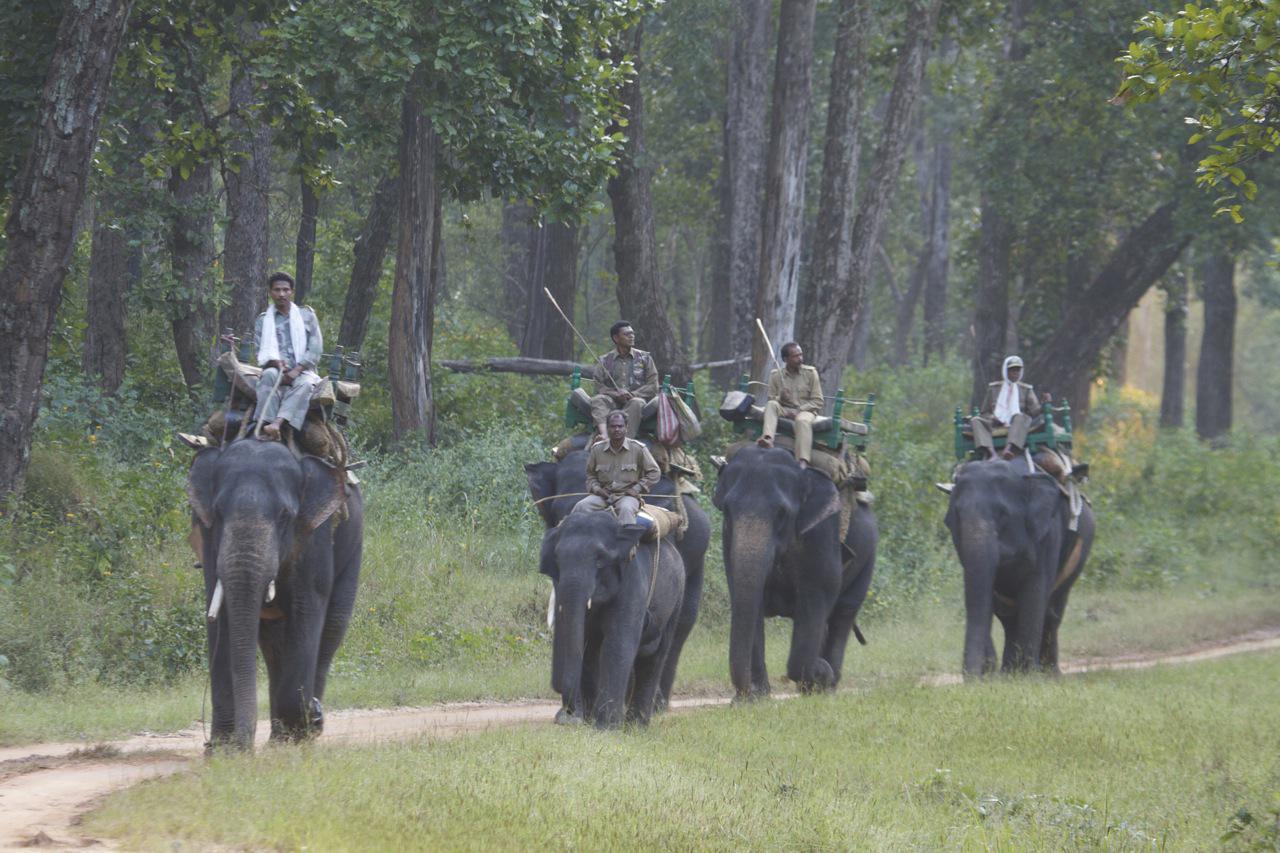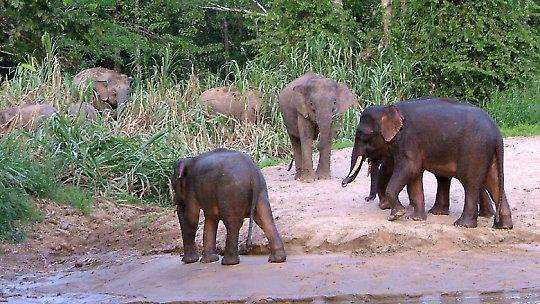The first image is the image on the left, the second image is the image on the right. Examine the images to the left and right. Is the description "There are less than three elephants in at least one of the images." accurate? Answer yes or no. No. The first image is the image on the left, the second image is the image on the right. Evaluate the accuracy of this statement regarding the images: "An image shows multiple people in a scene containing several elephants.". Is it true? Answer yes or no. Yes. 